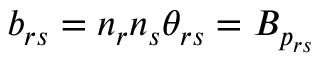Convert formula to latex. <formula><loc_0><loc_0><loc_500><loc_500>b _ { r s } = n _ { r } n _ { s } \theta _ { r s } = B _ { p _ { r s } }</formula> 